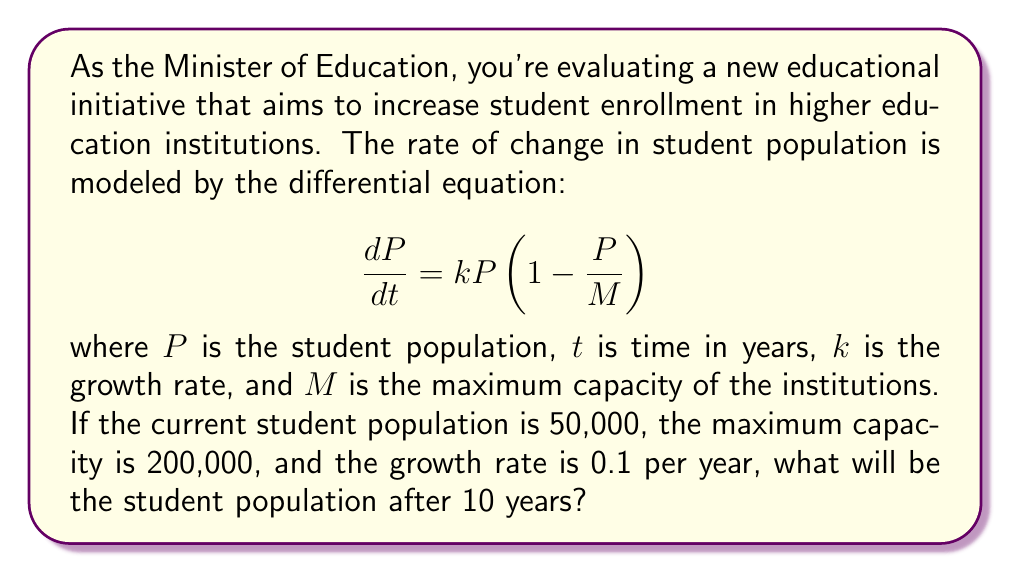Help me with this question. To solve this problem, we need to use the logistic growth model, which is a first-order differential equation. Let's approach this step-by-step:

1) The given differential equation is:

   $$\frac{dP}{dt} = kP(1 - \frac{P}{M})$$

2) We're given the following values:
   - Initial population, $P_0 = 50,000$
   - Maximum capacity, $M = 200,000$
   - Growth rate, $k = 0.1$ per year
   - Time period, $t = 10$ years

3) The solution to the logistic growth model is:

   $$P(t) = \frac{MP_0}{P_0 + (M-P_0)e^{-kt}}$$

4) Let's substitute our values:

   $$P(10) = \frac{200,000 \cdot 50,000}{50,000 + (200,000-50,000)e^{-0.1 \cdot 10}}$$

5) Simplify:

   $$P(10) = \frac{10,000,000,000}{50,000 + 150,000e^{-1}}$$

6) Calculate $e^{-1} \approx 0.3679$:

   $$P(10) = \frac{10,000,000,000}{50,000 + 150,000 \cdot 0.3679}$$

7) Simplify:

   $$P(10) = \frac{10,000,000,000}{50,000 + 55,185} \approx 95,016$$

Therefore, after 10 years, the student population will be approximately 95,016.
Answer: The student population after 10 years will be approximately 95,016. 